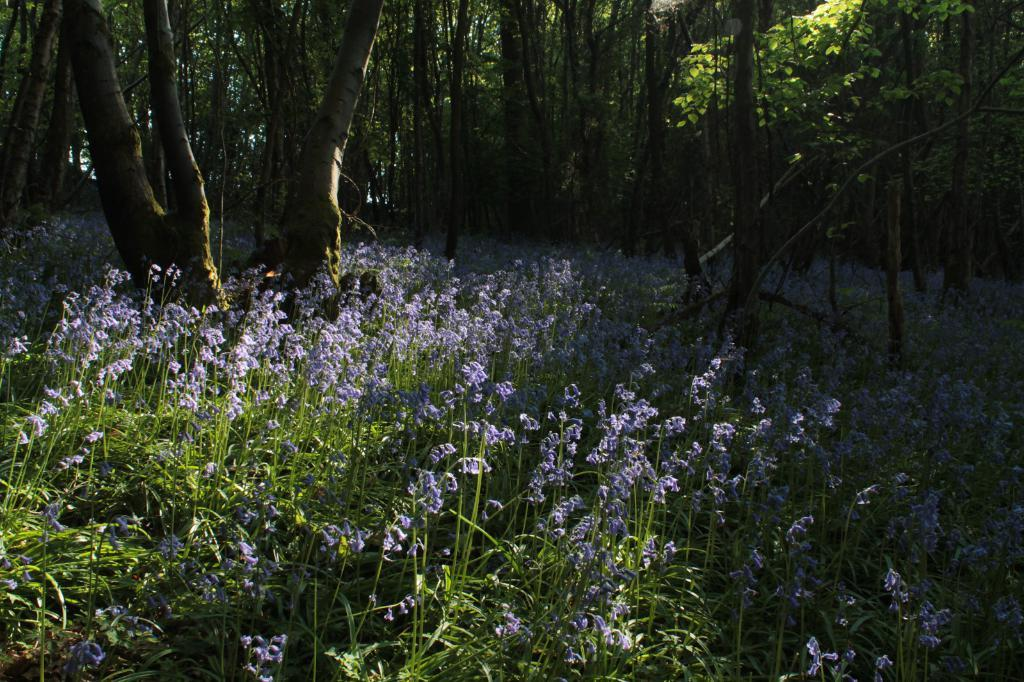What type of vegetation can be seen in the image? There are trees in the image. What color are the flowers on the plants in the image? The flowers on the plants in the image are purple. Can you see any airplanes flying over the trees in the image? There is no airplane visible in the image; it only features trees and purple flowers on plants. Are there any dinosaurs roaming among the trees in the image? There are no dinosaurs present in the image; it only features trees and purple flowers on plants. 